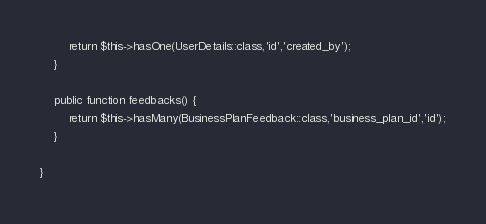Convert code to text. <code><loc_0><loc_0><loc_500><loc_500><_PHP_>        return $this->hasOne(UserDetails::class,'id','created_by');
    }

    public function feedbacks() {
        return $this->hasMany(BusinessPlanFeedback::class,'business_plan_id','id');
    }

}
</code> 